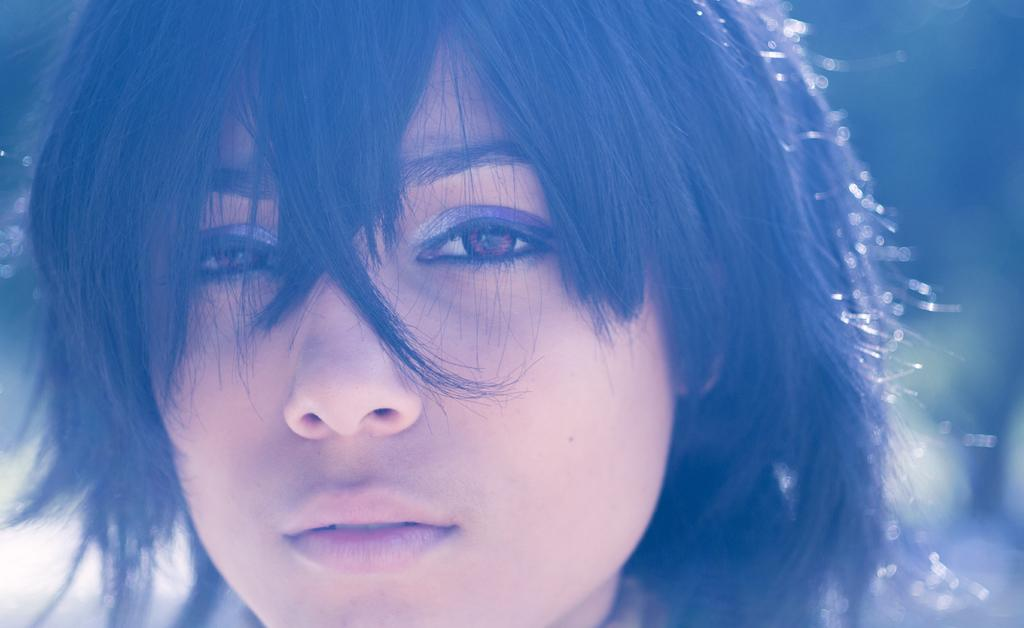What is the main subject of the image? There is a woman's face in the image. What can be seen in addition to the woman's face? The woman's hair is visible in the image. How would you describe the background of the image? The background of the image is blurred. Can you see a zipper on the woman's face in the image? No, there is no zipper present on the woman's face in the image. 